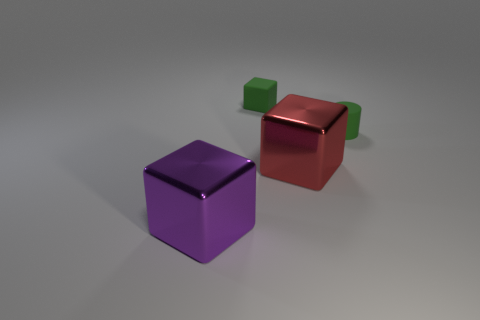Subtract all tiny cubes. How many cubes are left? 2 Add 4 brown metallic objects. How many objects exist? 8 Subtract all cubes. How many objects are left? 1 Add 4 big metal objects. How many big metal objects exist? 6 Subtract 0 cyan spheres. How many objects are left? 4 Subtract all large purple shiny things. Subtract all small yellow objects. How many objects are left? 3 Add 1 purple things. How many purple things are left? 2 